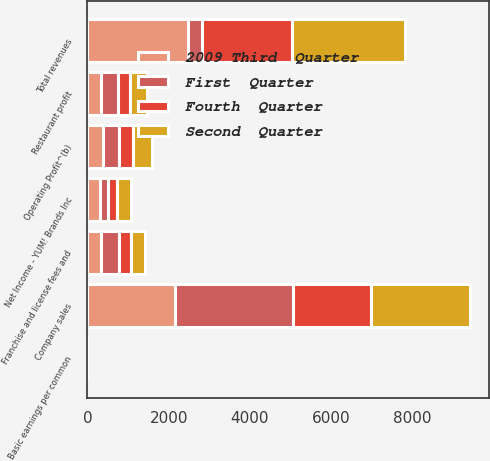Convert chart. <chart><loc_0><loc_0><loc_500><loc_500><stacked_bar_chart><ecel><fcel>Company sales<fcel>Franchise and license fees and<fcel>Total revenues<fcel>Restaurant profit<fcel>Operating Profit^(b)<fcel>Net Income - YUM! Brands Inc<fcel>Basic earnings per common<nl><fcel>Fourth  Quarter<fcel>1918<fcel>299<fcel>2217<fcel>308<fcel>351<fcel>218<fcel>0.47<nl><fcel>2009 Third  Quarter<fcel>2152<fcel>324<fcel>2476<fcel>324<fcel>394<fcel>303<fcel>0.65<nl><fcel>Second  Quarter<fcel>2432<fcel>346<fcel>2778<fcel>425<fcel>470<fcel>334<fcel>0.71<nl><fcel>First  Quarter<fcel>2911<fcel>454<fcel>351<fcel>422<fcel>375<fcel>216<fcel>0.46<nl></chart> 